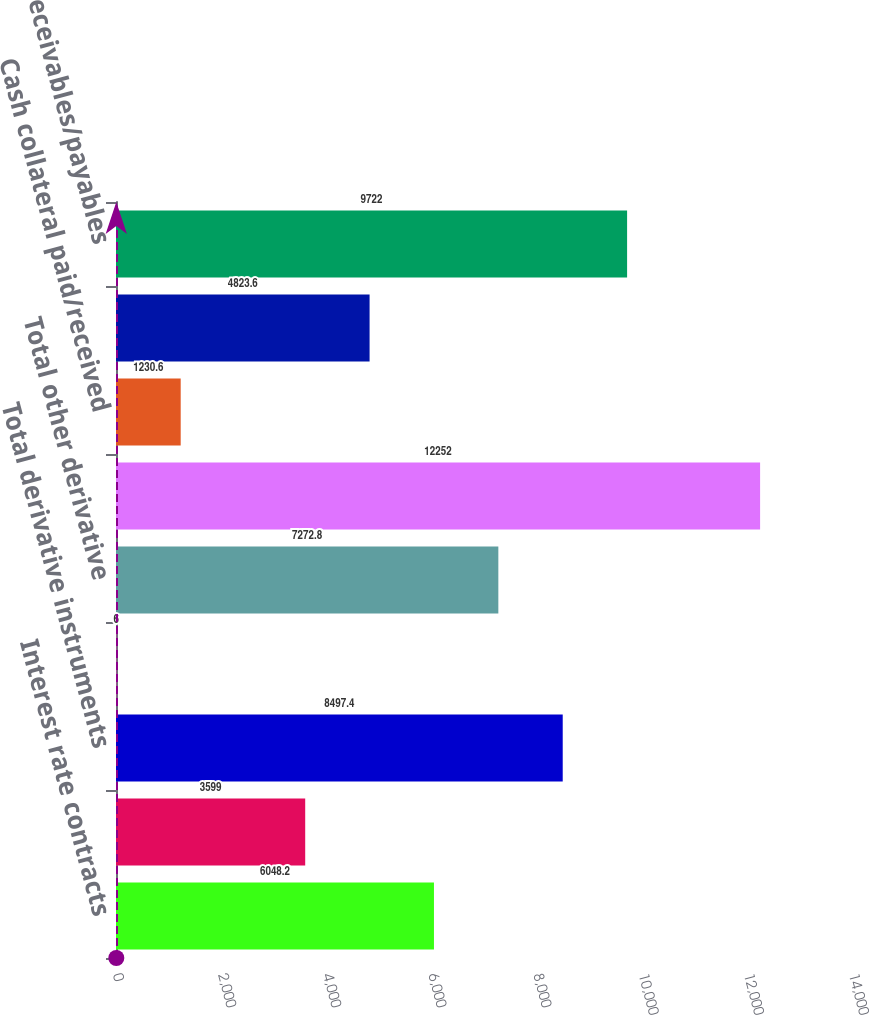<chart> <loc_0><loc_0><loc_500><loc_500><bar_chart><fcel>Interest rate contracts<fcel>Foreign exchange contracts<fcel>Total derivative instruments<fcel>Equity contracts<fcel>Total other derivative<fcel>Total derivatives<fcel>Cash collateral paid/received<fcel>Less Netting agreements and<fcel>Net receivables/payables<nl><fcel>6048.2<fcel>3599<fcel>8497.4<fcel>6<fcel>7272.8<fcel>12252<fcel>1230.6<fcel>4823.6<fcel>9722<nl></chart> 